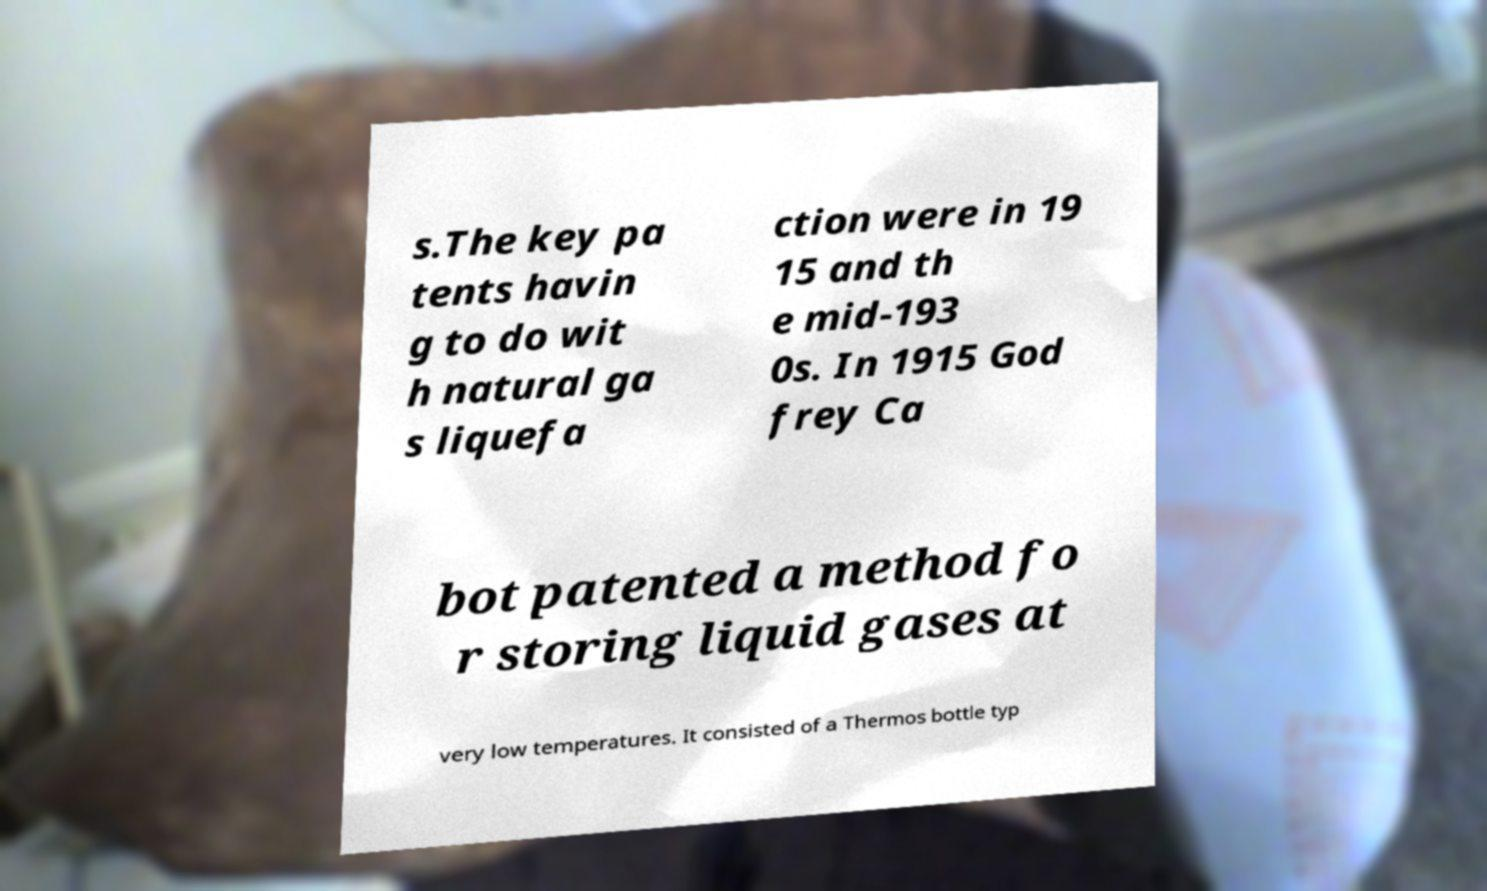I need the written content from this picture converted into text. Can you do that? s.The key pa tents havin g to do wit h natural ga s liquefa ction were in 19 15 and th e mid-193 0s. In 1915 God frey Ca bot patented a method fo r storing liquid gases at very low temperatures. It consisted of a Thermos bottle typ 